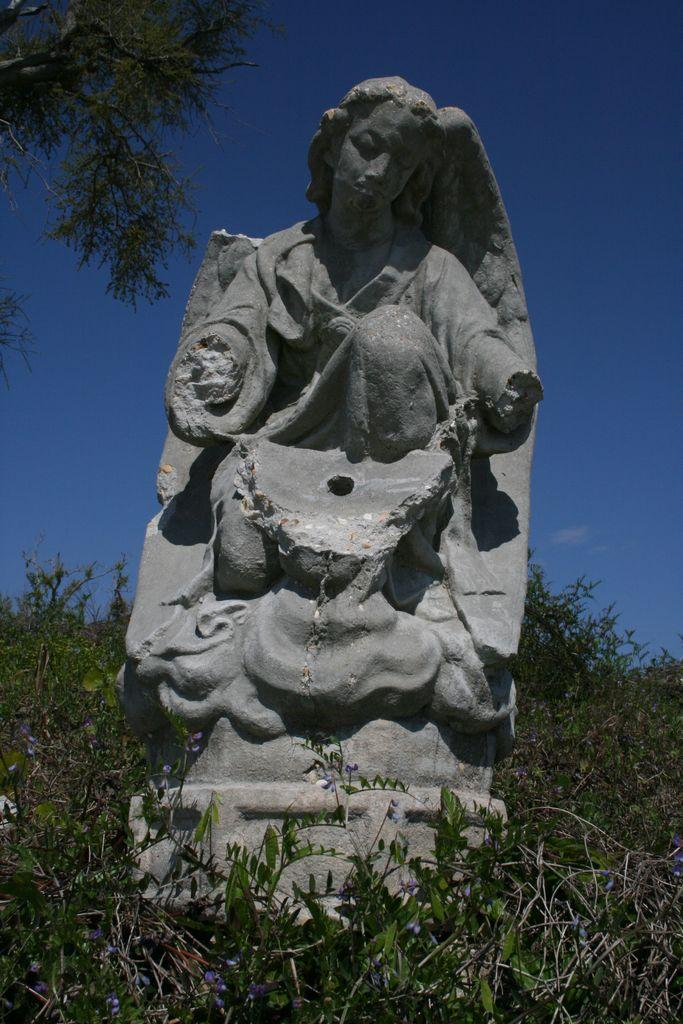What is the main subject of the image? There is a sculpture in the image. What surrounds the sculpture? There are many plants around the sculpture. What can be seen on the left side of the image? There is a tree on the left side of the image. What type of key is being used by the laborer in the image? There is no laborer or key present in the image, so this question cannot be answered. 